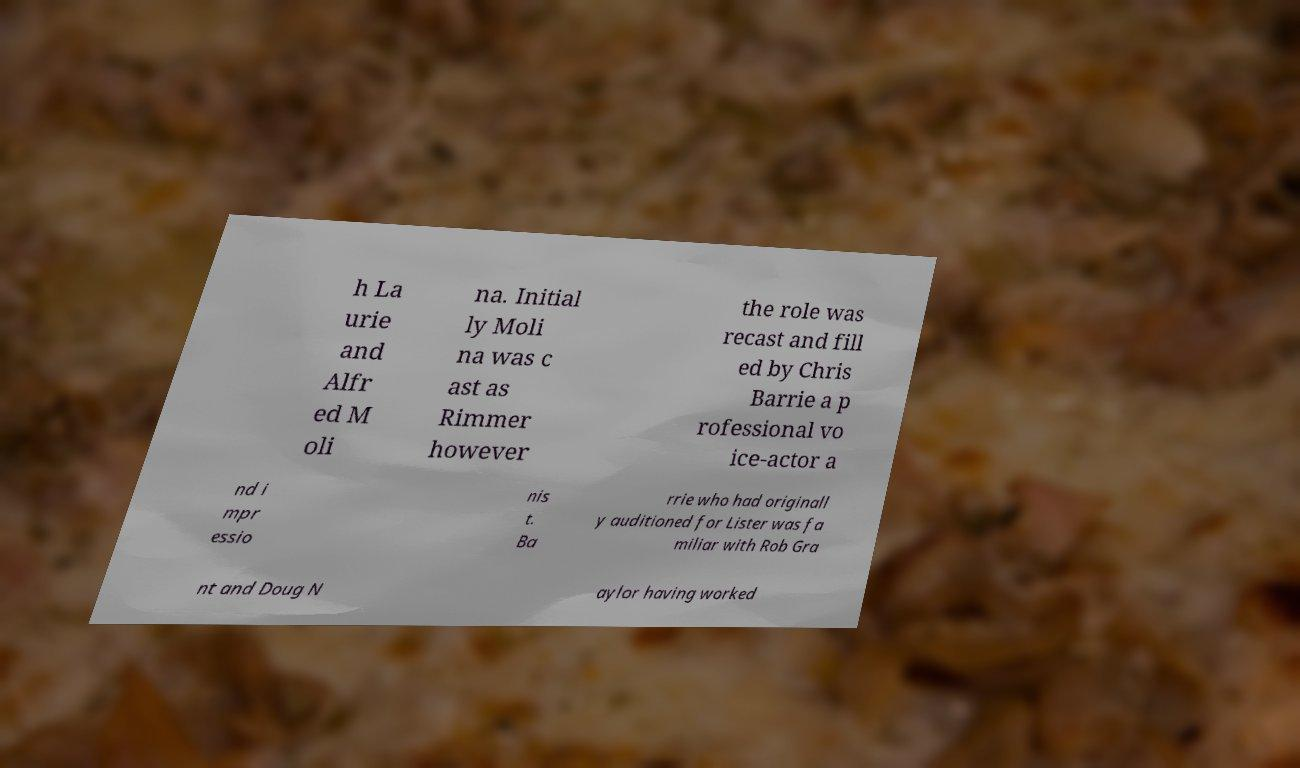Can you accurately transcribe the text from the provided image for me? h La urie and Alfr ed M oli na. Initial ly Moli na was c ast as Rimmer however the role was recast and fill ed by Chris Barrie a p rofessional vo ice-actor a nd i mpr essio nis t. Ba rrie who had originall y auditioned for Lister was fa miliar with Rob Gra nt and Doug N aylor having worked 